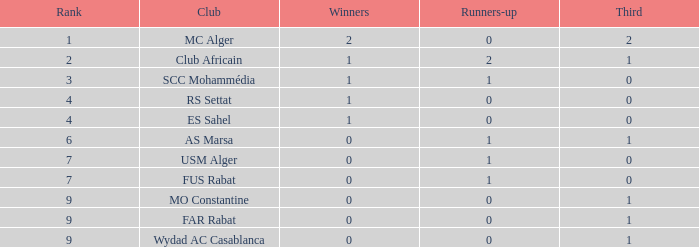Which level has one-third of 2, and conquerors below 2? None. 